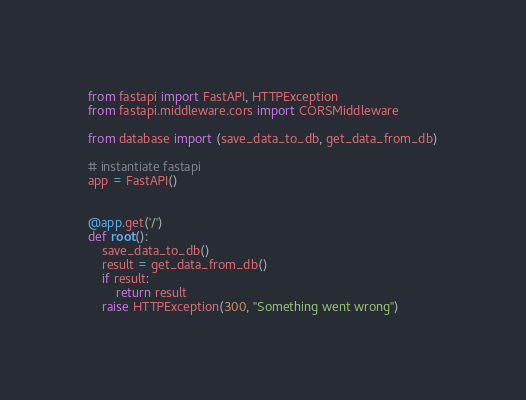Convert code to text. <code><loc_0><loc_0><loc_500><loc_500><_Python_>from fastapi import FastAPI, HTTPException
from fastapi.middleware.cors import CORSMiddleware

from database import (save_data_to_db, get_data_from_db)

# instantiate fastapi
app = FastAPI()


@app.get('/')
def root():
    save_data_to_db()
    result = get_data_from_db()
    if result:
        return result
    raise HTTPException(300, "Something went wrong")
</code> 